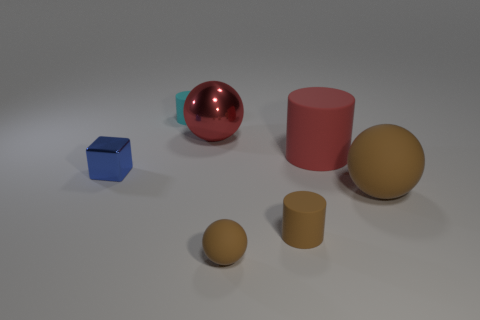There is a ball that is the same material as the small blue thing; what size is it?
Keep it short and to the point. Large. What material is the object that is left of the red ball and behind the large matte cylinder?
Provide a succinct answer. Rubber. Are there any brown objects behind the brown thing that is on the left side of the tiny matte cylinder in front of the blue thing?
Your answer should be compact. Yes. There is a rubber cylinder that is the same color as the metallic sphere; what is its size?
Ensure brevity in your answer.  Large. Are there any tiny things in front of the small blue metal cube?
Offer a very short reply. Yes. What number of other things are the same shape as the small shiny object?
Provide a succinct answer. 0. There is a sphere that is the same size as the red metal object; what color is it?
Make the answer very short. Brown. Are there fewer brown spheres that are in front of the red ball than rubber objects in front of the cyan thing?
Your response must be concise. Yes. How many large brown matte spheres are to the left of the shiny object that is left of the cylinder behind the big rubber cylinder?
Offer a very short reply. 0. There is a red thing that is the same shape as the cyan thing; what is its size?
Provide a succinct answer. Large. 